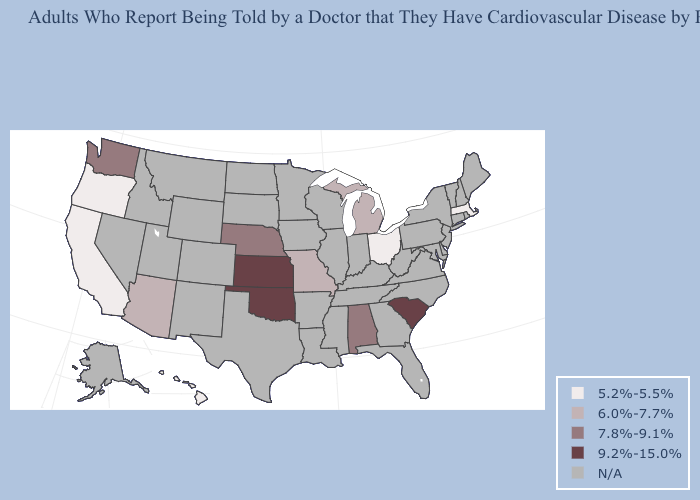Name the states that have a value in the range 5.2%-5.5%?
Keep it brief. California, Hawaii, Massachusetts, Ohio, Oregon. What is the highest value in the USA?
Quick response, please. 9.2%-15.0%. Which states have the lowest value in the USA?
Give a very brief answer. California, Hawaii, Massachusetts, Ohio, Oregon. What is the value of Arizona?
Be succinct. 6.0%-7.7%. Name the states that have a value in the range N/A?
Short answer required. Alaska, Arkansas, Colorado, Connecticut, Delaware, Florida, Georgia, Idaho, Illinois, Indiana, Iowa, Kentucky, Louisiana, Maine, Maryland, Minnesota, Mississippi, Montana, Nevada, New Hampshire, New Jersey, New Mexico, New York, North Carolina, North Dakota, Pennsylvania, Rhode Island, South Dakota, Tennessee, Texas, Utah, Vermont, Virginia, West Virginia, Wisconsin, Wyoming. Name the states that have a value in the range N/A?
Answer briefly. Alaska, Arkansas, Colorado, Connecticut, Delaware, Florida, Georgia, Idaho, Illinois, Indiana, Iowa, Kentucky, Louisiana, Maine, Maryland, Minnesota, Mississippi, Montana, Nevada, New Hampshire, New Jersey, New Mexico, New York, North Carolina, North Dakota, Pennsylvania, Rhode Island, South Dakota, Tennessee, Texas, Utah, Vermont, Virginia, West Virginia, Wisconsin, Wyoming. What is the value of Louisiana?
Write a very short answer. N/A. Which states have the highest value in the USA?
Quick response, please. Kansas, Oklahoma, South Carolina. Does the first symbol in the legend represent the smallest category?
Write a very short answer. Yes. What is the highest value in states that border Georgia?
Write a very short answer. 9.2%-15.0%. Name the states that have a value in the range N/A?
Concise answer only. Alaska, Arkansas, Colorado, Connecticut, Delaware, Florida, Georgia, Idaho, Illinois, Indiana, Iowa, Kentucky, Louisiana, Maine, Maryland, Minnesota, Mississippi, Montana, Nevada, New Hampshire, New Jersey, New Mexico, New York, North Carolina, North Dakota, Pennsylvania, Rhode Island, South Dakota, Tennessee, Texas, Utah, Vermont, Virginia, West Virginia, Wisconsin, Wyoming. Which states hav the highest value in the South?
Write a very short answer. Oklahoma, South Carolina. 